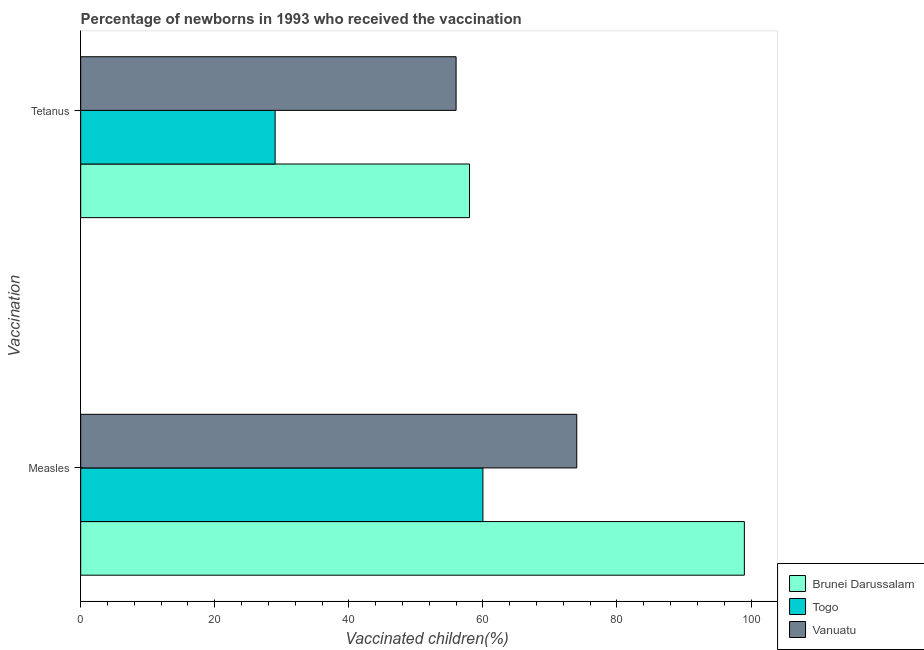How many different coloured bars are there?
Offer a very short reply. 3. Are the number of bars per tick equal to the number of legend labels?
Give a very brief answer. Yes. Are the number of bars on each tick of the Y-axis equal?
Offer a terse response. Yes. How many bars are there on the 2nd tick from the top?
Ensure brevity in your answer.  3. How many bars are there on the 1st tick from the bottom?
Ensure brevity in your answer.  3. What is the label of the 2nd group of bars from the top?
Ensure brevity in your answer.  Measles. What is the percentage of newborns who received vaccination for tetanus in Vanuatu?
Your answer should be compact. 56. Across all countries, what is the maximum percentage of newborns who received vaccination for measles?
Make the answer very short. 99. Across all countries, what is the minimum percentage of newborns who received vaccination for tetanus?
Keep it short and to the point. 29. In which country was the percentage of newborns who received vaccination for measles maximum?
Offer a terse response. Brunei Darussalam. In which country was the percentage of newborns who received vaccination for tetanus minimum?
Provide a succinct answer. Togo. What is the total percentage of newborns who received vaccination for tetanus in the graph?
Keep it short and to the point. 143. What is the difference between the percentage of newborns who received vaccination for tetanus in Togo and that in Brunei Darussalam?
Offer a very short reply. -29. What is the difference between the percentage of newborns who received vaccination for tetanus in Togo and the percentage of newborns who received vaccination for measles in Vanuatu?
Give a very brief answer. -45. What is the average percentage of newborns who received vaccination for measles per country?
Your answer should be very brief. 77.67. What is the difference between the percentage of newborns who received vaccination for measles and percentage of newborns who received vaccination for tetanus in Brunei Darussalam?
Your response must be concise. 41. What is the ratio of the percentage of newborns who received vaccination for measles in Vanuatu to that in Brunei Darussalam?
Provide a short and direct response. 0.75. In how many countries, is the percentage of newborns who received vaccination for measles greater than the average percentage of newborns who received vaccination for measles taken over all countries?
Keep it short and to the point. 1. What does the 3rd bar from the top in Tetanus represents?
Your response must be concise. Brunei Darussalam. What does the 1st bar from the bottom in Measles represents?
Your answer should be compact. Brunei Darussalam. Are all the bars in the graph horizontal?
Your answer should be compact. Yes. What is the difference between two consecutive major ticks on the X-axis?
Give a very brief answer. 20. Does the graph contain grids?
Your answer should be very brief. No. Where does the legend appear in the graph?
Provide a short and direct response. Bottom right. How many legend labels are there?
Give a very brief answer. 3. How are the legend labels stacked?
Your answer should be very brief. Vertical. What is the title of the graph?
Give a very brief answer. Percentage of newborns in 1993 who received the vaccination. What is the label or title of the X-axis?
Keep it short and to the point. Vaccinated children(%)
. What is the label or title of the Y-axis?
Your response must be concise. Vaccination. What is the Vaccinated children(%)
 in Brunei Darussalam in Measles?
Ensure brevity in your answer.  99. What is the Vaccinated children(%)
 of Togo in Tetanus?
Your answer should be very brief. 29. Across all Vaccination, what is the minimum Vaccinated children(%)
 in Togo?
Offer a terse response. 29. What is the total Vaccinated children(%)
 of Brunei Darussalam in the graph?
Provide a succinct answer. 157. What is the total Vaccinated children(%)
 in Togo in the graph?
Your answer should be compact. 89. What is the total Vaccinated children(%)
 in Vanuatu in the graph?
Provide a succinct answer. 130. What is the difference between the Vaccinated children(%)
 of Togo in Measles and that in Tetanus?
Your response must be concise. 31. What is the difference between the Vaccinated children(%)
 of Brunei Darussalam in Measles and the Vaccinated children(%)
 of Vanuatu in Tetanus?
Offer a terse response. 43. What is the difference between the Vaccinated children(%)
 of Togo in Measles and the Vaccinated children(%)
 of Vanuatu in Tetanus?
Provide a short and direct response. 4. What is the average Vaccinated children(%)
 of Brunei Darussalam per Vaccination?
Your answer should be compact. 78.5. What is the average Vaccinated children(%)
 of Togo per Vaccination?
Ensure brevity in your answer.  44.5. What is the difference between the Vaccinated children(%)
 of Brunei Darussalam and Vaccinated children(%)
 of Togo in Measles?
Your answer should be very brief. 39. What is the difference between the Vaccinated children(%)
 of Brunei Darussalam and Vaccinated children(%)
 of Vanuatu in Measles?
Give a very brief answer. 25. What is the difference between the Vaccinated children(%)
 of Togo and Vaccinated children(%)
 of Vanuatu in Measles?
Offer a terse response. -14. What is the difference between the Vaccinated children(%)
 of Brunei Darussalam and Vaccinated children(%)
 of Vanuatu in Tetanus?
Give a very brief answer. 2. What is the ratio of the Vaccinated children(%)
 in Brunei Darussalam in Measles to that in Tetanus?
Make the answer very short. 1.71. What is the ratio of the Vaccinated children(%)
 in Togo in Measles to that in Tetanus?
Ensure brevity in your answer.  2.07. What is the ratio of the Vaccinated children(%)
 in Vanuatu in Measles to that in Tetanus?
Your response must be concise. 1.32. What is the difference between the highest and the second highest Vaccinated children(%)
 in Togo?
Keep it short and to the point. 31. What is the difference between the highest and the second highest Vaccinated children(%)
 in Vanuatu?
Make the answer very short. 18. What is the difference between the highest and the lowest Vaccinated children(%)
 in Brunei Darussalam?
Keep it short and to the point. 41. 